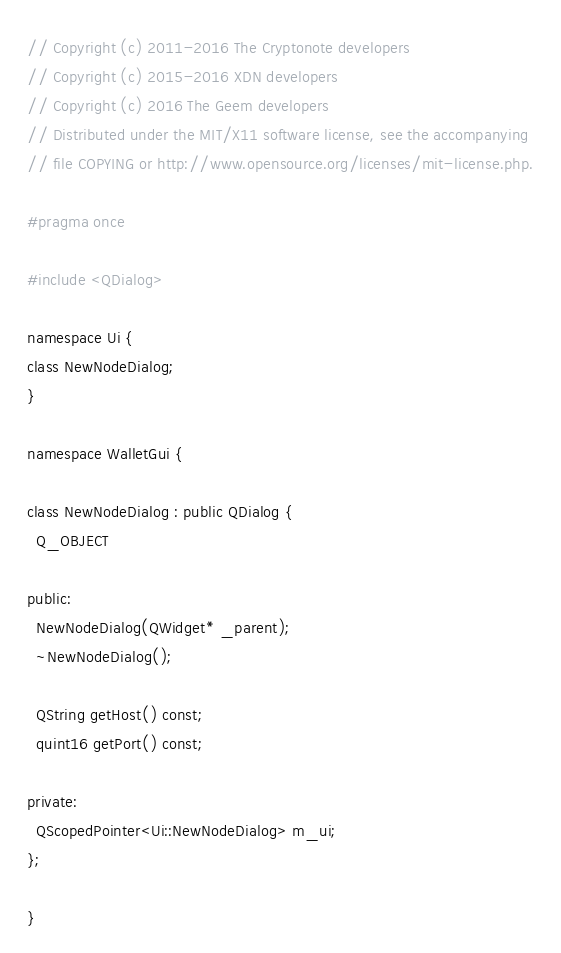<code> <loc_0><loc_0><loc_500><loc_500><_C_>// Copyright (c) 2011-2016 The Cryptonote developers
// Copyright (c) 2015-2016 XDN developers
// Copyright (c) 2016 The Geem developers
// Distributed under the MIT/X11 software license, see the accompanying
// file COPYING or http://www.opensource.org/licenses/mit-license.php.

#pragma once

#include <QDialog>

namespace Ui {
class NewNodeDialog;
}

namespace WalletGui {

class NewNodeDialog : public QDialog {
  Q_OBJECT

public:
  NewNodeDialog(QWidget* _parent);
  ~NewNodeDialog();

  QString getHost() const;
  quint16 getPort() const;

private:
  QScopedPointer<Ui::NewNodeDialog> m_ui;
};

}
</code> 